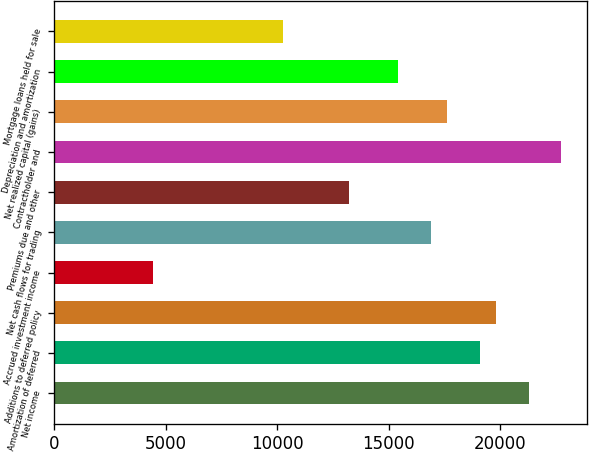Convert chart. <chart><loc_0><loc_0><loc_500><loc_500><bar_chart><fcel>Net income<fcel>Amortization of deferred<fcel>Additions to deferred policy<fcel>Accrued investment income<fcel>Net cash flows for trading<fcel>Premiums due and other<fcel>Contractholder and<fcel>Net realized capital (gains)<fcel>Depreciation and amortization<fcel>Mortgage loans held for sale<nl><fcel>21294<fcel>19091.2<fcel>19825.5<fcel>4406.44<fcel>16888.5<fcel>13217.3<fcel>22762.4<fcel>17622.8<fcel>15420<fcel>10280.4<nl></chart> 